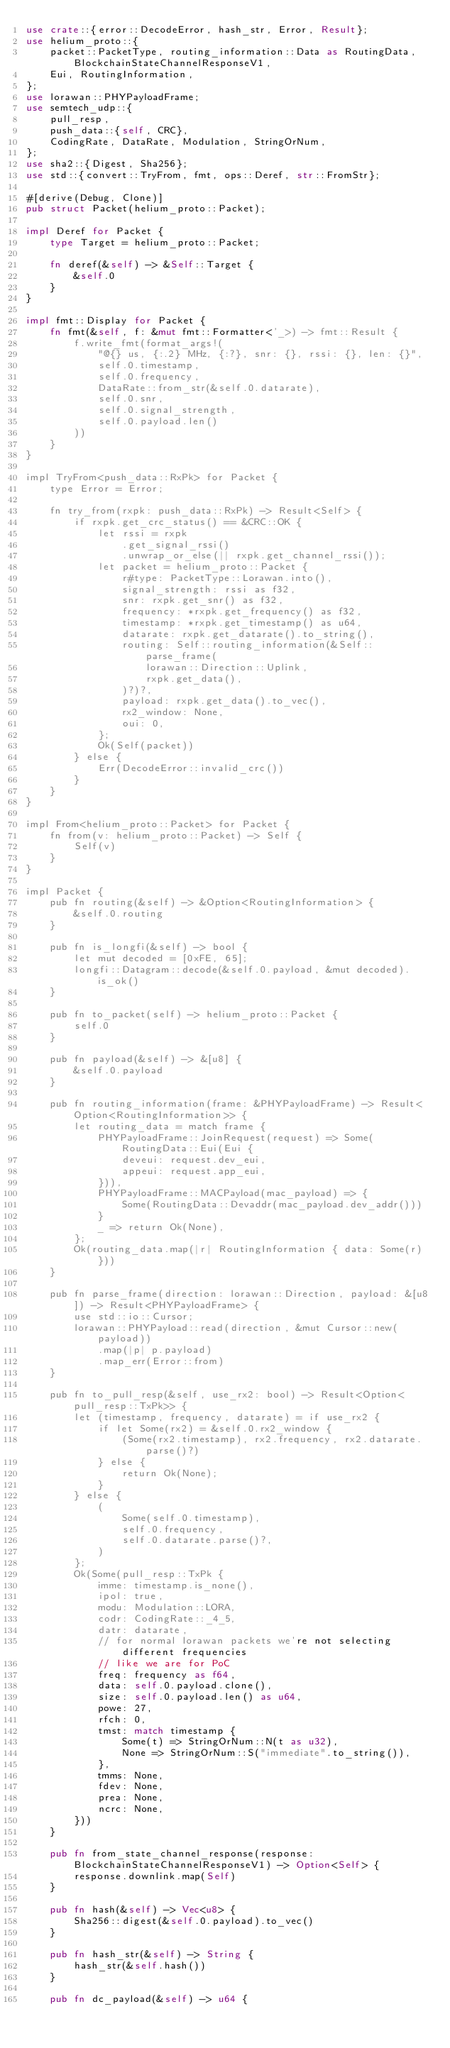<code> <loc_0><loc_0><loc_500><loc_500><_Rust_>use crate::{error::DecodeError, hash_str, Error, Result};
use helium_proto::{
    packet::PacketType, routing_information::Data as RoutingData, BlockchainStateChannelResponseV1,
    Eui, RoutingInformation,
};
use lorawan::PHYPayloadFrame;
use semtech_udp::{
    pull_resp,
    push_data::{self, CRC},
    CodingRate, DataRate, Modulation, StringOrNum,
};
use sha2::{Digest, Sha256};
use std::{convert::TryFrom, fmt, ops::Deref, str::FromStr};

#[derive(Debug, Clone)]
pub struct Packet(helium_proto::Packet);

impl Deref for Packet {
    type Target = helium_proto::Packet;

    fn deref(&self) -> &Self::Target {
        &self.0
    }
}

impl fmt::Display for Packet {
    fn fmt(&self, f: &mut fmt::Formatter<'_>) -> fmt::Result {
        f.write_fmt(format_args!(
            "@{} us, {:.2} MHz, {:?}, snr: {}, rssi: {}, len: {}",
            self.0.timestamp,
            self.0.frequency,
            DataRate::from_str(&self.0.datarate),
            self.0.snr,
            self.0.signal_strength,
            self.0.payload.len()
        ))
    }
}

impl TryFrom<push_data::RxPk> for Packet {
    type Error = Error;

    fn try_from(rxpk: push_data::RxPk) -> Result<Self> {
        if rxpk.get_crc_status() == &CRC::OK {
            let rssi = rxpk
                .get_signal_rssi()
                .unwrap_or_else(|| rxpk.get_channel_rssi());
            let packet = helium_proto::Packet {
                r#type: PacketType::Lorawan.into(),
                signal_strength: rssi as f32,
                snr: rxpk.get_snr() as f32,
                frequency: *rxpk.get_frequency() as f32,
                timestamp: *rxpk.get_timestamp() as u64,
                datarate: rxpk.get_datarate().to_string(),
                routing: Self::routing_information(&Self::parse_frame(
                    lorawan::Direction::Uplink,
                    rxpk.get_data(),
                )?)?,
                payload: rxpk.get_data().to_vec(),
                rx2_window: None,
                oui: 0,
            };
            Ok(Self(packet))
        } else {
            Err(DecodeError::invalid_crc())
        }
    }
}

impl From<helium_proto::Packet> for Packet {
    fn from(v: helium_proto::Packet) -> Self {
        Self(v)
    }
}

impl Packet {
    pub fn routing(&self) -> &Option<RoutingInformation> {
        &self.0.routing
    }

    pub fn is_longfi(&self) -> bool {
        let mut decoded = [0xFE, 65];
        longfi::Datagram::decode(&self.0.payload, &mut decoded).is_ok()
    }

    pub fn to_packet(self) -> helium_proto::Packet {
        self.0
    }

    pub fn payload(&self) -> &[u8] {
        &self.0.payload
    }

    pub fn routing_information(frame: &PHYPayloadFrame) -> Result<Option<RoutingInformation>> {
        let routing_data = match frame {
            PHYPayloadFrame::JoinRequest(request) => Some(RoutingData::Eui(Eui {
                deveui: request.dev_eui,
                appeui: request.app_eui,
            })),
            PHYPayloadFrame::MACPayload(mac_payload) => {
                Some(RoutingData::Devaddr(mac_payload.dev_addr()))
            }
            _ => return Ok(None),
        };
        Ok(routing_data.map(|r| RoutingInformation { data: Some(r) }))
    }

    pub fn parse_frame(direction: lorawan::Direction, payload: &[u8]) -> Result<PHYPayloadFrame> {
        use std::io::Cursor;
        lorawan::PHYPayload::read(direction, &mut Cursor::new(payload))
            .map(|p| p.payload)
            .map_err(Error::from)
    }

    pub fn to_pull_resp(&self, use_rx2: bool) -> Result<Option<pull_resp::TxPk>> {
        let (timestamp, frequency, datarate) = if use_rx2 {
            if let Some(rx2) = &self.0.rx2_window {
                (Some(rx2.timestamp), rx2.frequency, rx2.datarate.parse()?)
            } else {
                return Ok(None);
            }
        } else {
            (
                Some(self.0.timestamp),
                self.0.frequency,
                self.0.datarate.parse()?,
            )
        };
        Ok(Some(pull_resp::TxPk {
            imme: timestamp.is_none(),
            ipol: true,
            modu: Modulation::LORA,
            codr: CodingRate::_4_5,
            datr: datarate,
            // for normal lorawan packets we're not selecting different frequencies
            // like we are for PoC
            freq: frequency as f64,
            data: self.0.payload.clone(),
            size: self.0.payload.len() as u64,
            powe: 27,
            rfch: 0,
            tmst: match timestamp {
                Some(t) => StringOrNum::N(t as u32),
                None => StringOrNum::S("immediate".to_string()),
            },
            tmms: None,
            fdev: None,
            prea: None,
            ncrc: None,
        }))
    }

    pub fn from_state_channel_response(response: BlockchainStateChannelResponseV1) -> Option<Self> {
        response.downlink.map(Self)
    }

    pub fn hash(&self) -> Vec<u8> {
        Sha256::digest(&self.0.payload).to_vec()
    }

    pub fn hash_str(&self) -> String {
        hash_str(&self.hash())
    }

    pub fn dc_payload(&self) -> u64 {</code> 